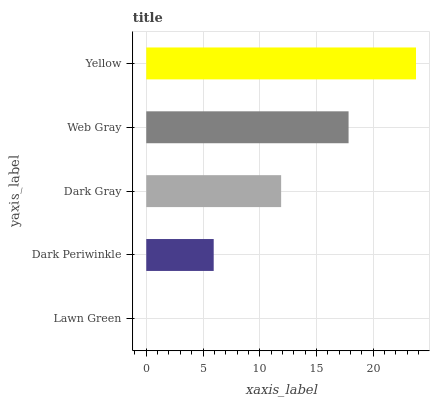Is Lawn Green the minimum?
Answer yes or no. Yes. Is Yellow the maximum?
Answer yes or no. Yes. Is Dark Periwinkle the minimum?
Answer yes or no. No. Is Dark Periwinkle the maximum?
Answer yes or no. No. Is Dark Periwinkle greater than Lawn Green?
Answer yes or no. Yes. Is Lawn Green less than Dark Periwinkle?
Answer yes or no. Yes. Is Lawn Green greater than Dark Periwinkle?
Answer yes or no. No. Is Dark Periwinkle less than Lawn Green?
Answer yes or no. No. Is Dark Gray the high median?
Answer yes or no. Yes. Is Dark Gray the low median?
Answer yes or no. Yes. Is Lawn Green the high median?
Answer yes or no. No. Is Lawn Green the low median?
Answer yes or no. No. 